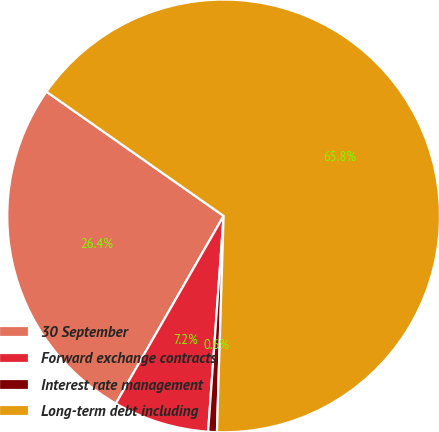Convert chart. <chart><loc_0><loc_0><loc_500><loc_500><pie_chart><fcel>30 September<fcel>Forward exchange contracts<fcel>Interest rate management<fcel>Long-term debt including<nl><fcel>26.43%<fcel>7.16%<fcel>0.65%<fcel>65.76%<nl></chart> 